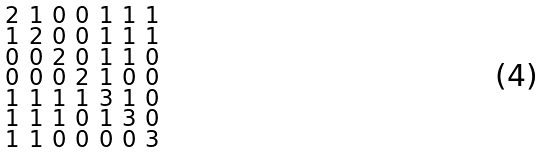<formula> <loc_0><loc_0><loc_500><loc_500>\begin{smallmatrix} 2 & 1 & 0 & 0 & 1 & 1 & 1 \\ 1 & 2 & 0 & 0 & 1 & 1 & 1 \\ 0 & 0 & 2 & 0 & 1 & 1 & 0 \\ 0 & 0 & 0 & 2 & 1 & 0 & 0 \\ 1 & 1 & 1 & 1 & 3 & 1 & 0 \\ 1 & 1 & 1 & 0 & 1 & 3 & 0 \\ 1 & 1 & 0 & 0 & 0 & 0 & 3 \end{smallmatrix}</formula> 